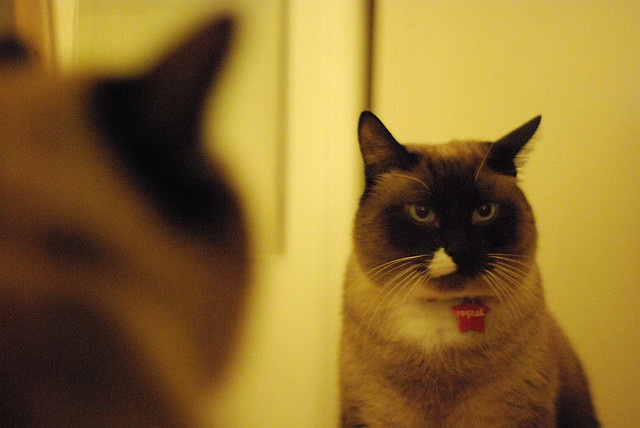Describe the objects in this image and their specific colors. I can see cat in maroon, black, and olive tones and cat in maroon, black, and olive tones in this image. 